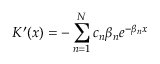<formula> <loc_0><loc_0><loc_500><loc_500>K ^ { \prime } ( x ) = - \sum _ { n = 1 } ^ { N } c _ { n } \beta _ { n } e ^ { - \beta _ { n } x }</formula> 